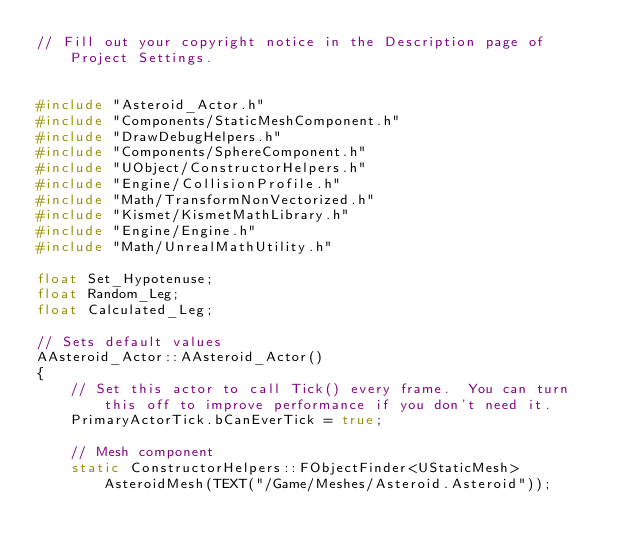Convert code to text. <code><loc_0><loc_0><loc_500><loc_500><_C++_>// Fill out your copyright notice in the Description page of Project Settings.


#include "Asteroid_Actor.h"
#include "Components/StaticMeshComponent.h"
#include "DrawDebugHelpers.h"
#include "Components/SphereComponent.h"
#include "UObject/ConstructorHelpers.h"
#include "Engine/CollisionProfile.h"
#include "Math/TransformNonVectorized.h"
#include "Kismet/KismetMathLibrary.h"
#include "Engine/Engine.h"
#include "Math/UnrealMathUtility.h"

float Set_Hypotenuse;
float Random_Leg;
float Calculated_Leg;

// Sets default values
AAsteroid_Actor::AAsteroid_Actor()
{
 	// Set this actor to call Tick() every frame.  You can turn this off to improve performance if you don't need it.
	PrimaryActorTick.bCanEverTick = true;

	// Mesh component
	static ConstructorHelpers::FObjectFinder<UStaticMesh> AsteroidMesh(TEXT("/Game/Meshes/Asteroid.Asteroid"));</code> 